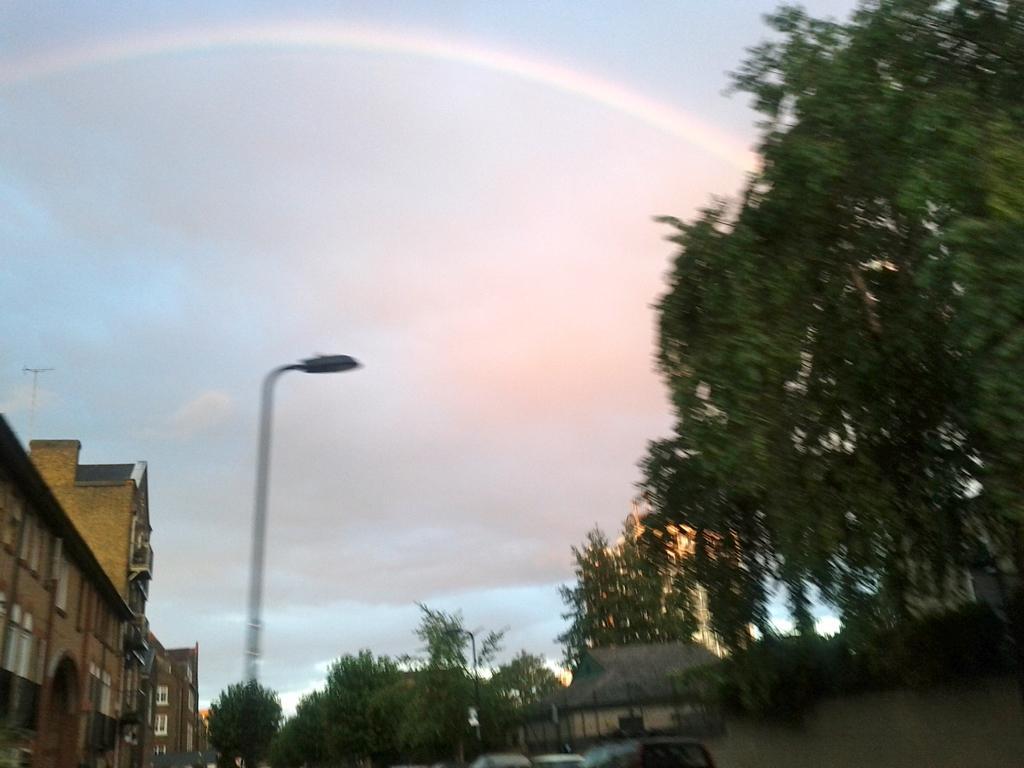How would you summarize this image in a sentence or two? On the right side of the picture there are trees. In the center of the picture there are cars, house, trees and a street light. On the left there is a building. In the sky there is a rainbow. 